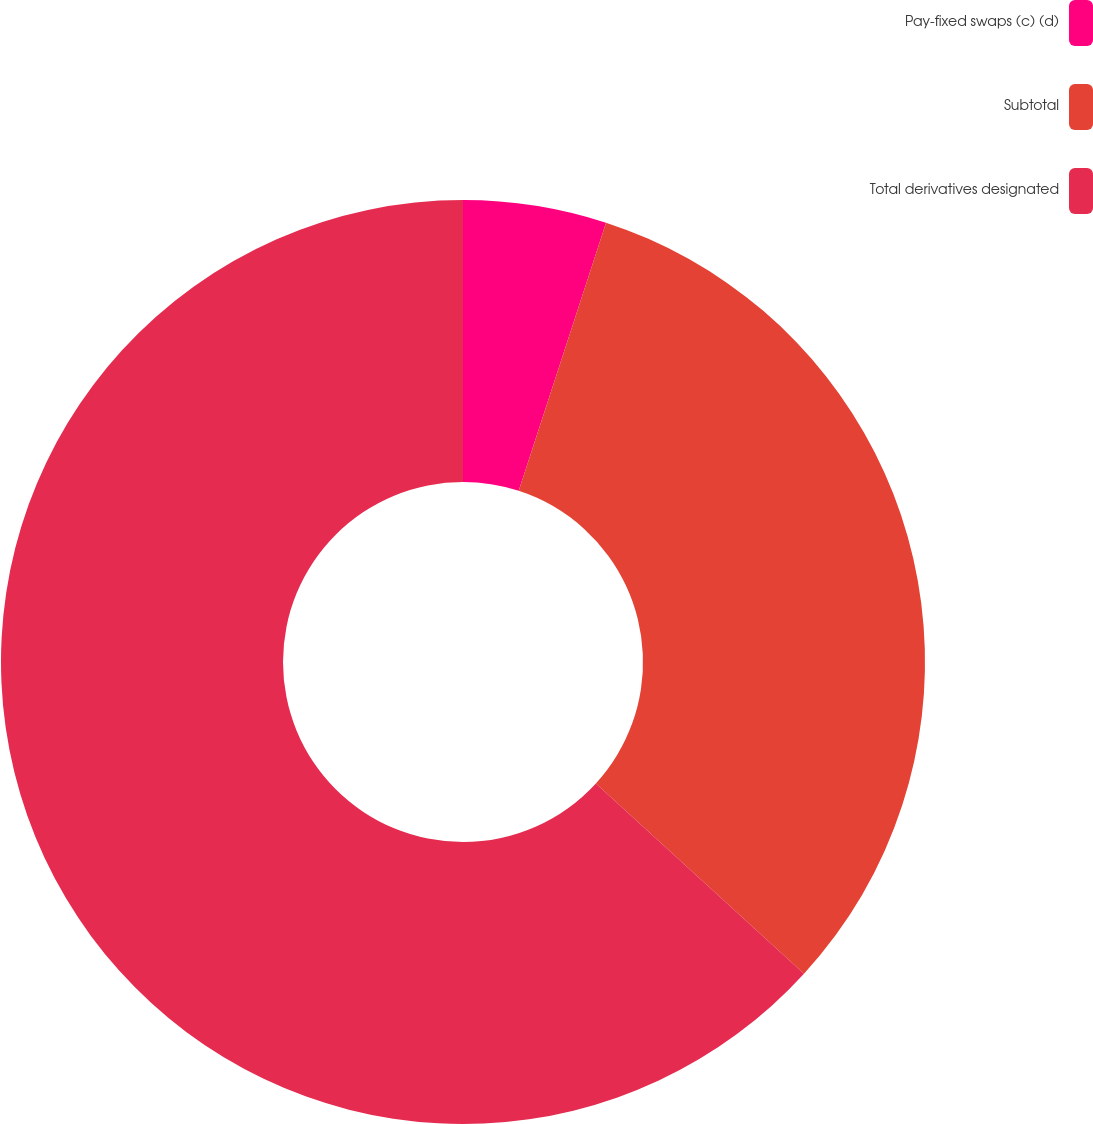<chart> <loc_0><loc_0><loc_500><loc_500><pie_chart><fcel>Pay-fixed swaps (c) (d)<fcel>Subtotal<fcel>Total derivatives designated<nl><fcel>5.01%<fcel>31.78%<fcel>63.22%<nl></chart> 